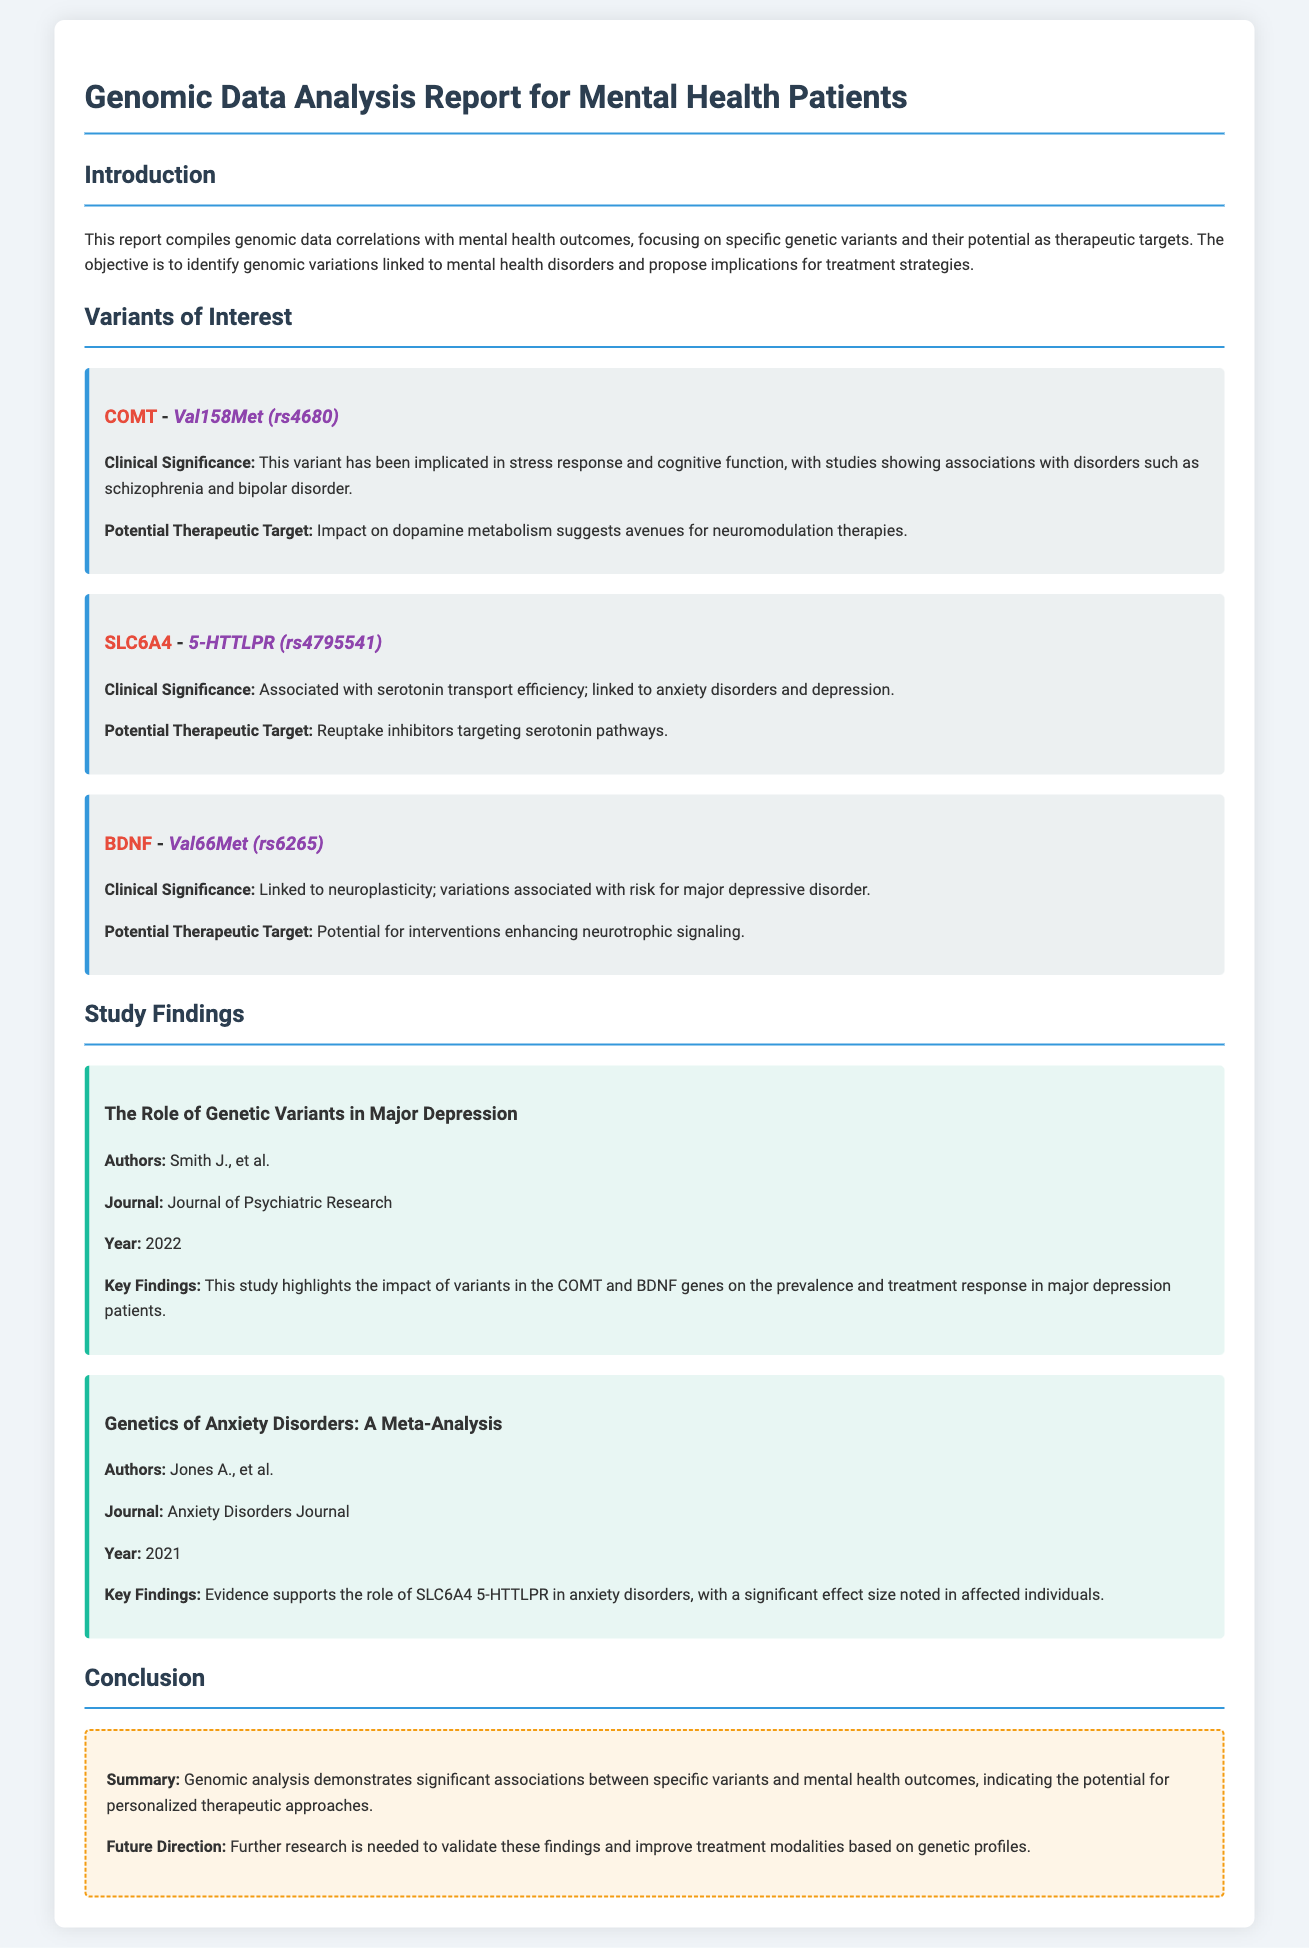What is the title of the report? The title is displayed in the header of the document.
Answer: Genomic Data Analysis Report for Mental Health Patients What gene is associated with the variant Val158Met? This gene is listed in the Variants of Interest section.
Answer: COMT What is the potential therapeutic target for the SLC6A4 variant? This information is provided under the potential therapeutic target for the variant in the report.
Answer: Reuptake inhibitors targeting serotonin pathways Who is the author of the study on major depression? This author's name is specified in the study findings section.
Answer: Smith J What year was the "Genetics of Anxiety Disorders: A Meta-Analysis" published? The publishing year is mentioned in the study findings section of the report.
Answer: 2021 What significant finding is associated with the BDNF variant Val66Met? This is highlighted in the Clinical Significance of the variant specifically.
Answer: Risk for major depressive disorder What is the summary provided in the conclusion? The summary is stated in the concluding section of the document.
Answer: Significant associations between specific variants and mental health outcomes How many variants of interest are detailed in the report? The count can be determined by reviewing the Variants of Interest section, which lists them all.
Answer: Three 